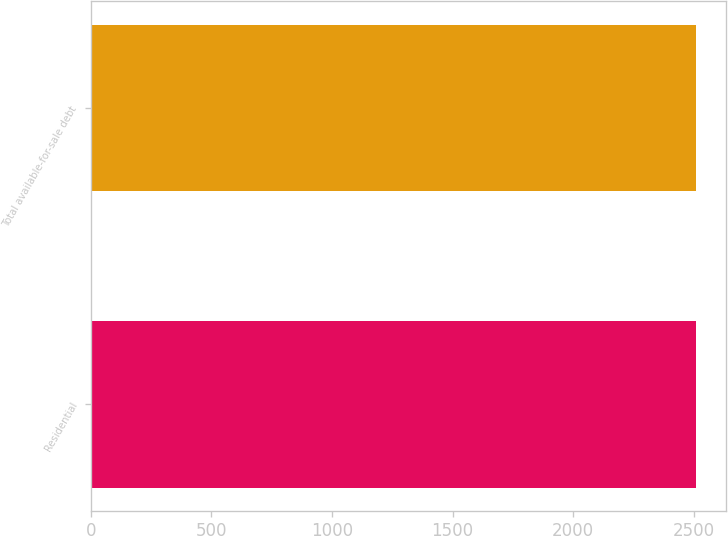<chart> <loc_0><loc_0><loc_500><loc_500><bar_chart><fcel>Residential<fcel>Total available-for-sale debt<nl><fcel>2509<fcel>2509.1<nl></chart> 